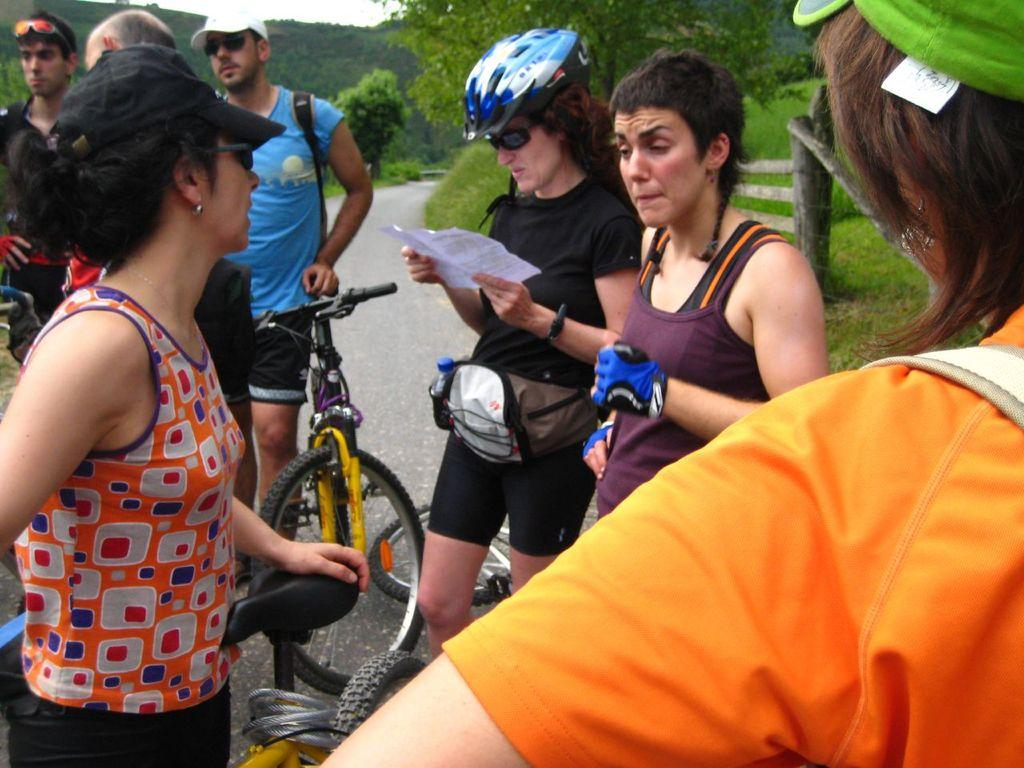What can be seen in the image? There is a group of people in the image. Where are the people located? The people are standing on the road. What are some of the people wearing on their heads? Some people are wearing helmets, and some are wearing hats. What else can be seen in the image? There are trees visible in the image, and there is a bicycle on the road. What type of tooth is visible in the image? There is no tooth visible in the image. What is the reason for the people standing on the road? The image does not provide information about the reason for the people standing on the road. 